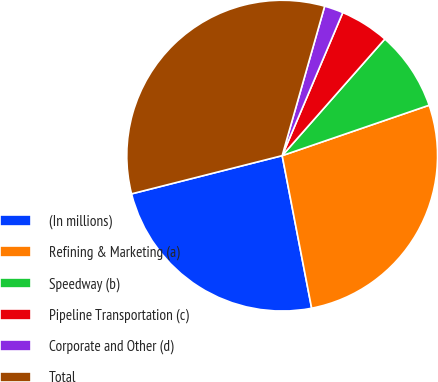Convert chart. <chart><loc_0><loc_0><loc_500><loc_500><pie_chart><fcel>(In millions)<fcel>Refining & Marketing (a)<fcel>Speedway (b)<fcel>Pipeline Transportation (c)<fcel>Corporate and Other (d)<fcel>Total<nl><fcel>24.08%<fcel>27.22%<fcel>8.25%<fcel>5.11%<fcel>1.97%<fcel>33.36%<nl></chart> 